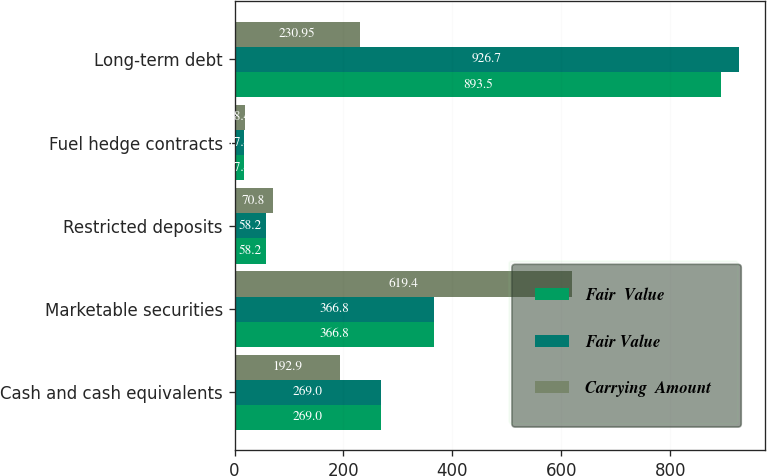Convert chart. <chart><loc_0><loc_0><loc_500><loc_500><stacked_bar_chart><ecel><fcel>Cash and cash equivalents<fcel>Marketable securities<fcel>Restricted deposits<fcel>Fuel hedge contracts<fcel>Long-term debt<nl><fcel>Fair  Value<fcel>269<fcel>366.8<fcel>58.2<fcel>17.4<fcel>893.5<nl><fcel>Fair Value<fcel>269<fcel>366.8<fcel>58.2<fcel>17.4<fcel>926.7<nl><fcel>Carrying  Amount<fcel>192.9<fcel>619.4<fcel>70.8<fcel>18.4<fcel>230.95<nl></chart> 